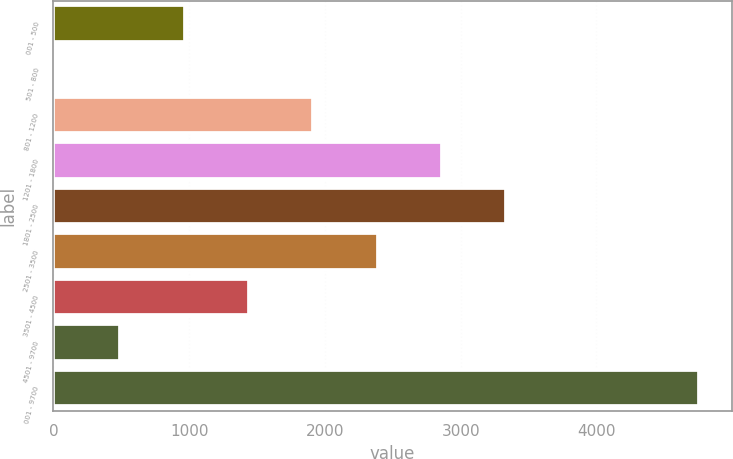Convert chart to OTSL. <chart><loc_0><loc_0><loc_500><loc_500><bar_chart><fcel>001 - 500<fcel>501 - 800<fcel>801 - 1200<fcel>1201 - 1800<fcel>1801 - 2500<fcel>2501 - 3500<fcel>3501 - 4500<fcel>4501 - 9700<fcel>001 - 9700<nl><fcel>966.2<fcel>18<fcel>1914.4<fcel>2862.6<fcel>3336.7<fcel>2388.5<fcel>1440.3<fcel>492.1<fcel>4759<nl></chart> 